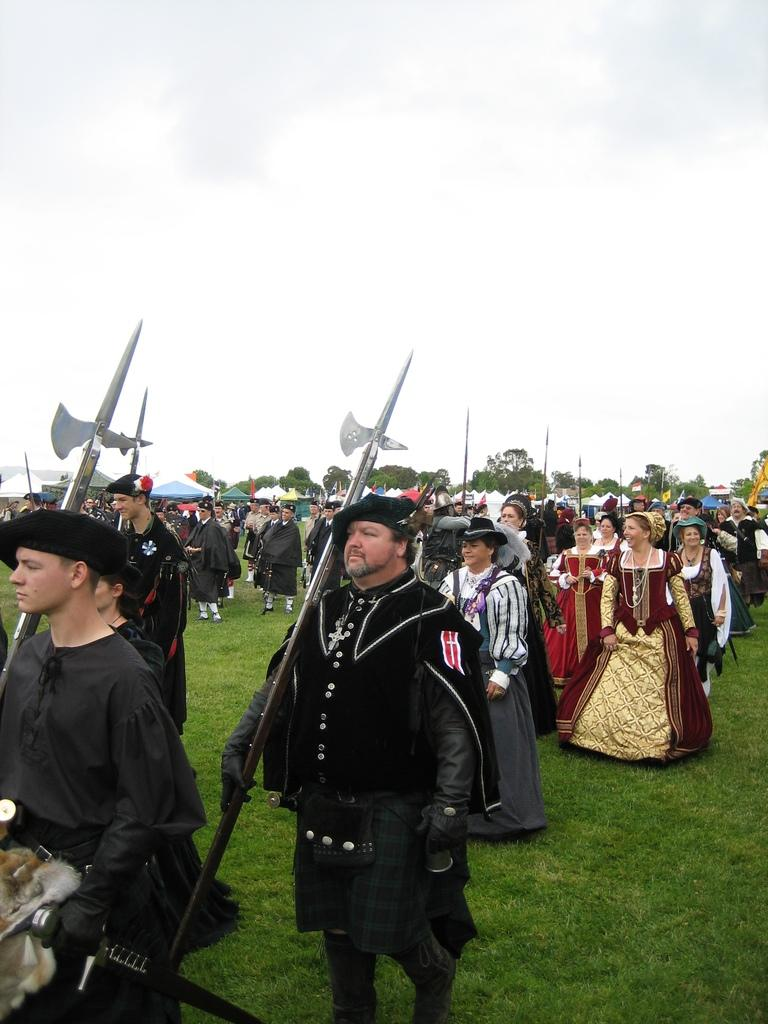How many people are in the image? There is a group of people in the image, but the exact number is not specified. Where are the people located in the image? The people are on the grass in the image. What are some of the people holding in their hands? Some people are holding weapons in their hands. What can be seen in the background of the image? There are tents, trees, and the sky visible in the background of the image. What type of pollution can be seen in the image? There is no pollution visible in the image; it features a group of people on the grass with weapons and a background of tents, trees, and the sky. How many babies are present in the image? There is no mention of babies in the image; it features a group of people holding weapons and a background of tents, trees, and the sky. 